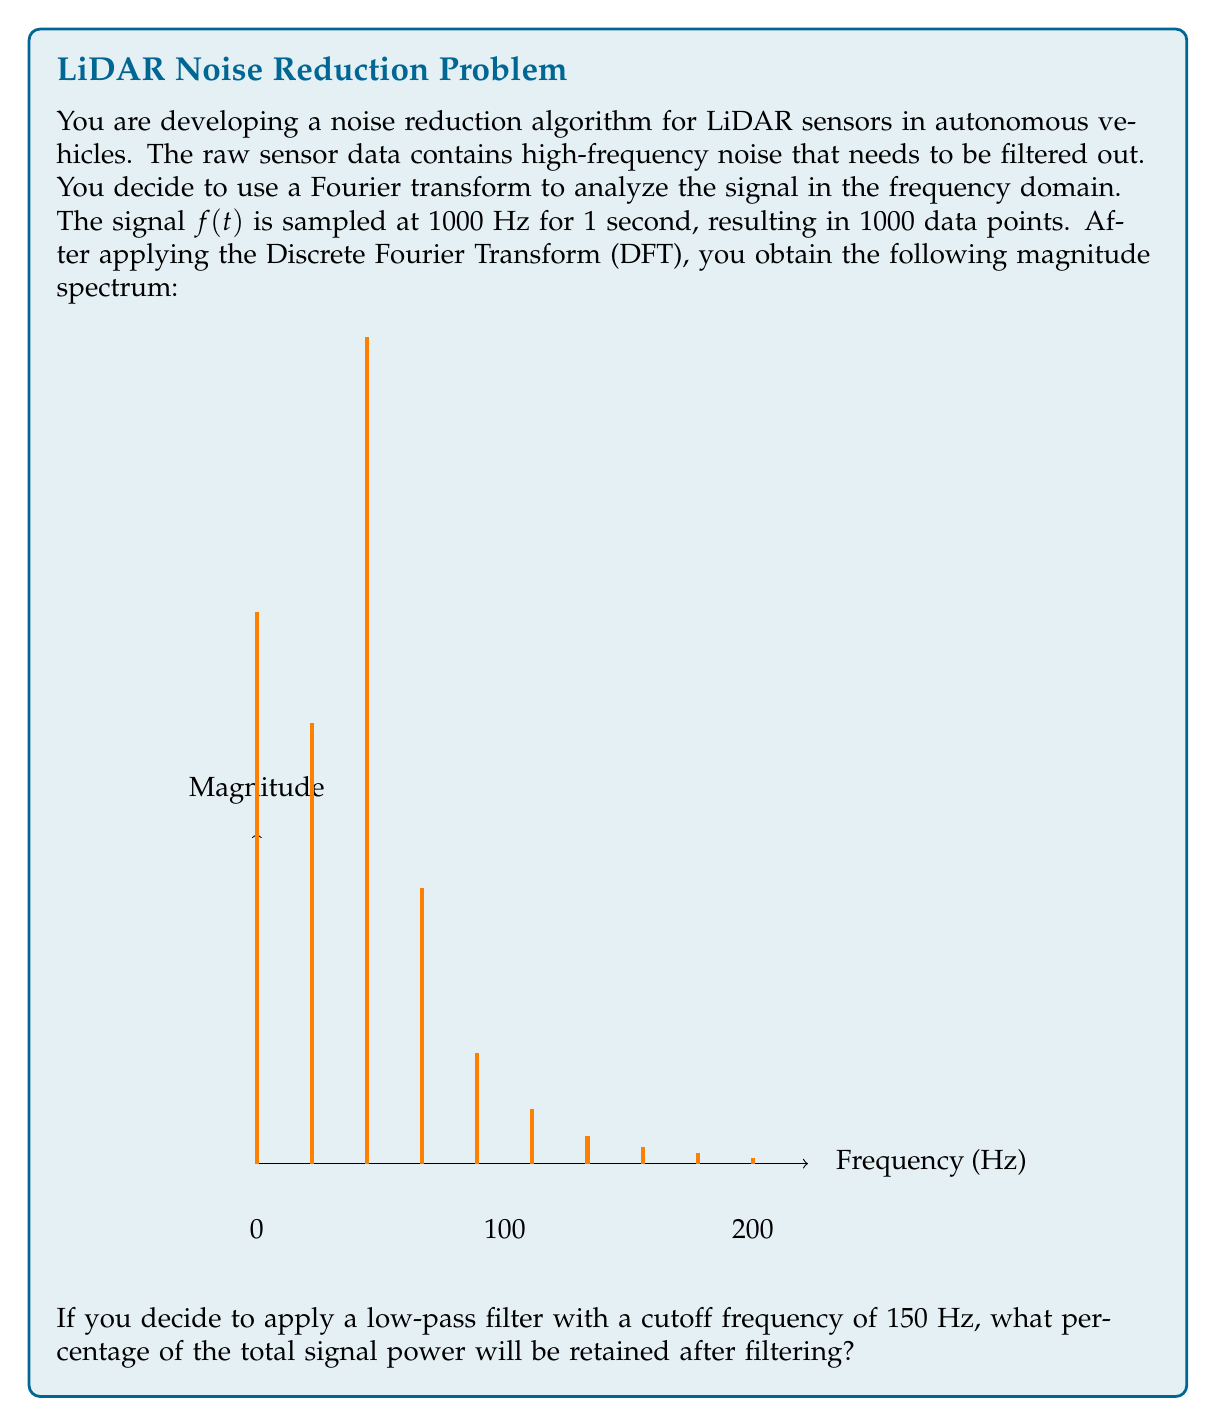Teach me how to tackle this problem. Let's approach this step-by-step:

1) First, we need to understand what the graph represents. Each bar in the graph represents the magnitude of a frequency component, with the x-axis showing frequency in Hz. The graph shows the first 10 components, spanning 0-200 Hz (as 1000 Hz / 5 = 200 Hz per division).

2) In a DFT, the power of a signal component is proportional to the square of its magnitude. The total power of the signal is the sum of the powers of all components.

3) Let's calculate the total power:

   $$P_{total} = 10^2 + 8^2 + 15^2 + 5^2 + 2^2 + 1^2 + 0.5^2 + 0.3^2 + 0.2^2 + 0.1^2 = 390.39$$

4) Now, we need to determine which components will be retained after applying the 150 Hz low-pass filter. This will include the first 7.5 bars (as 150 Hz is 75% of the way to the 8th bar).

5) Let's calculate the power of the retained components:

   $$P_{retained} = 10^2 + 8^2 + 15^2 + 5^2 + 2^2 + 1^2 + 0.5^2 + (0.75 * 0.3^2) = 390.3175$$

6) To calculate the percentage of power retained, we use:

   $$\text{Percentage retained} = \frac{P_{retained}}{P_{total}} * 100\%$$

7) Plugging in our values:

   $$\text{Percentage retained} = \frac{390.3175}{390.39} * 100\% = 99.98\%$$
Answer: 99.98% 